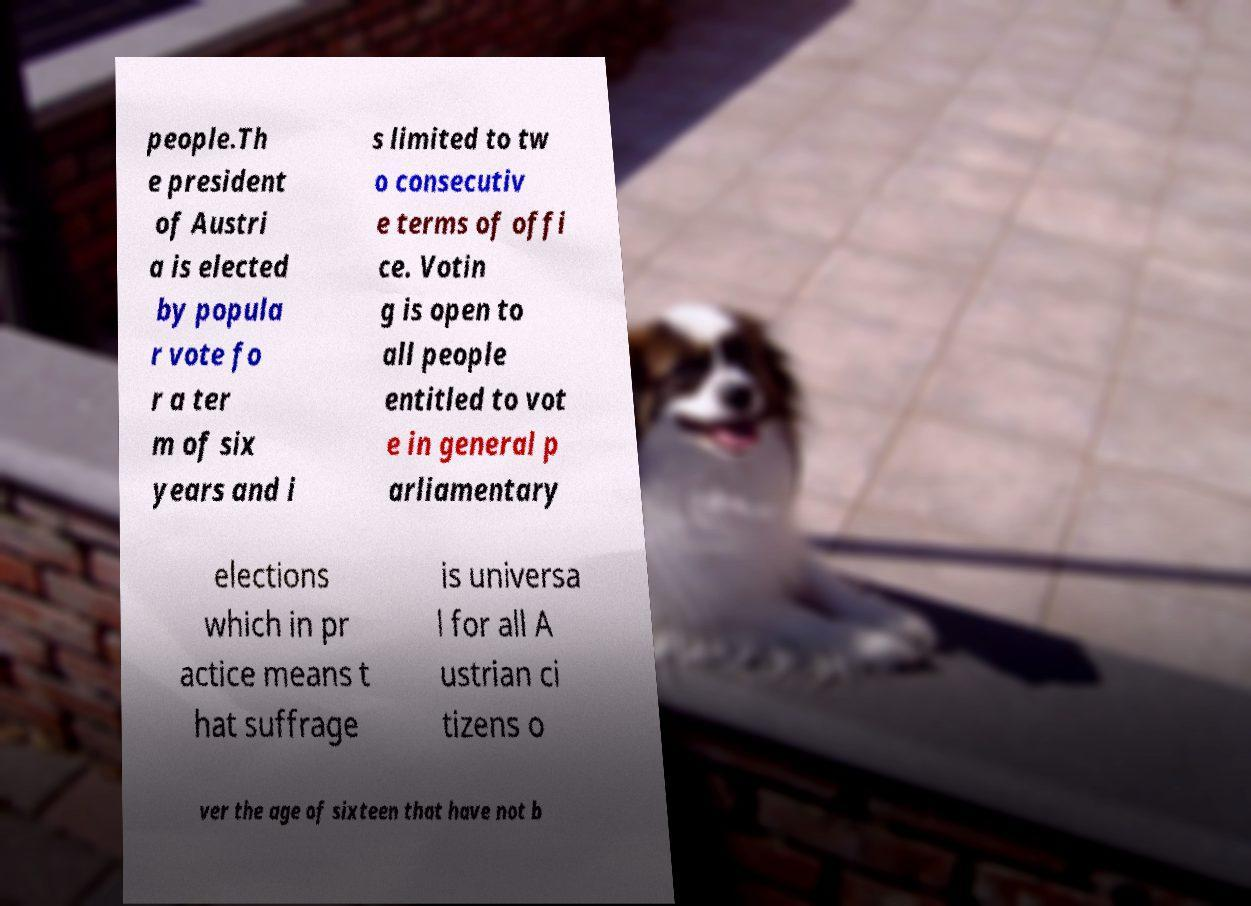Can you read and provide the text displayed in the image?This photo seems to have some interesting text. Can you extract and type it out for me? people.Th e president of Austri a is elected by popula r vote fo r a ter m of six years and i s limited to tw o consecutiv e terms of offi ce. Votin g is open to all people entitled to vot e in general p arliamentary elections which in pr actice means t hat suffrage is universa l for all A ustrian ci tizens o ver the age of sixteen that have not b 